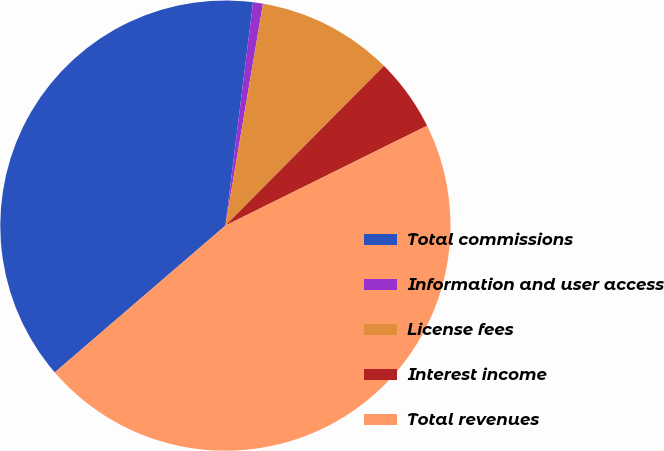Convert chart. <chart><loc_0><loc_0><loc_500><loc_500><pie_chart><fcel>Total commissions<fcel>Information and user access<fcel>License fees<fcel>Interest income<fcel>Total revenues<nl><fcel>38.27%<fcel>0.71%<fcel>9.77%<fcel>5.24%<fcel>46.01%<nl></chart> 